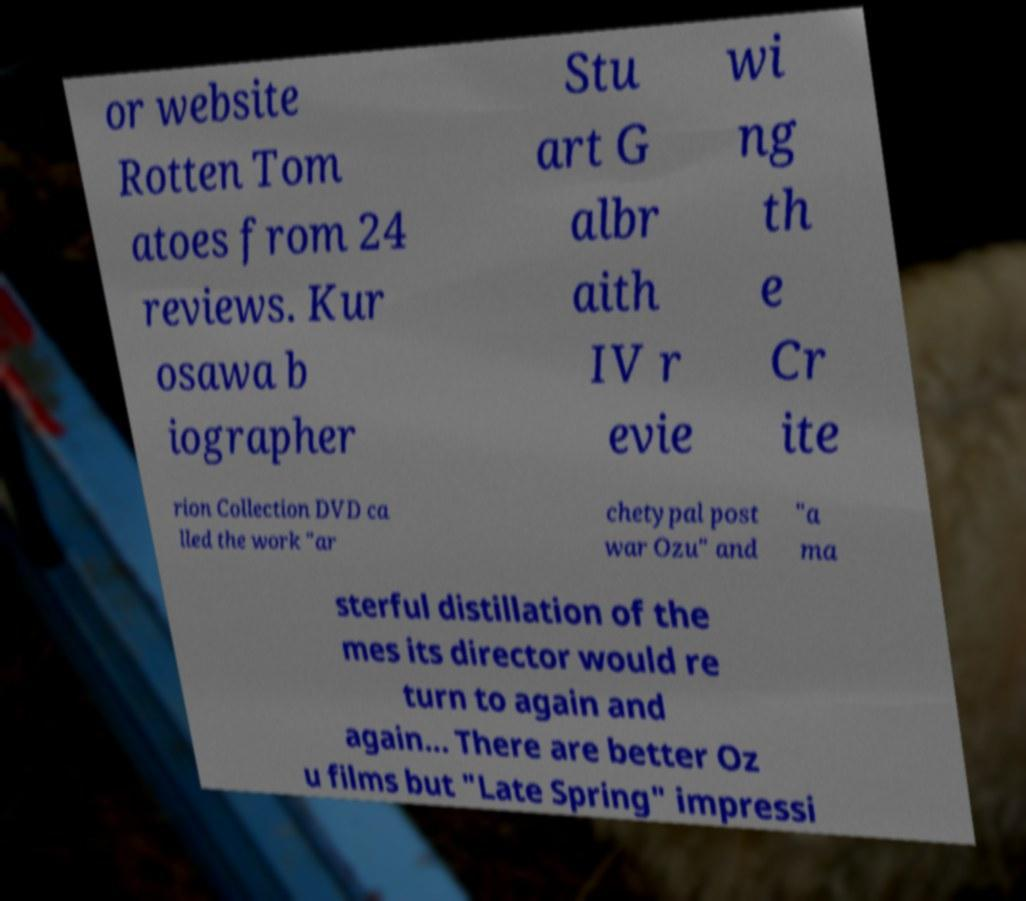Please read and relay the text visible in this image. What does it say? or website Rotten Tom atoes from 24 reviews. Kur osawa b iographer Stu art G albr aith IV r evie wi ng th e Cr ite rion Collection DVD ca lled the work "ar chetypal post war Ozu" and "a ma sterful distillation of the mes its director would re turn to again and again... There are better Oz u films but "Late Spring" impressi 